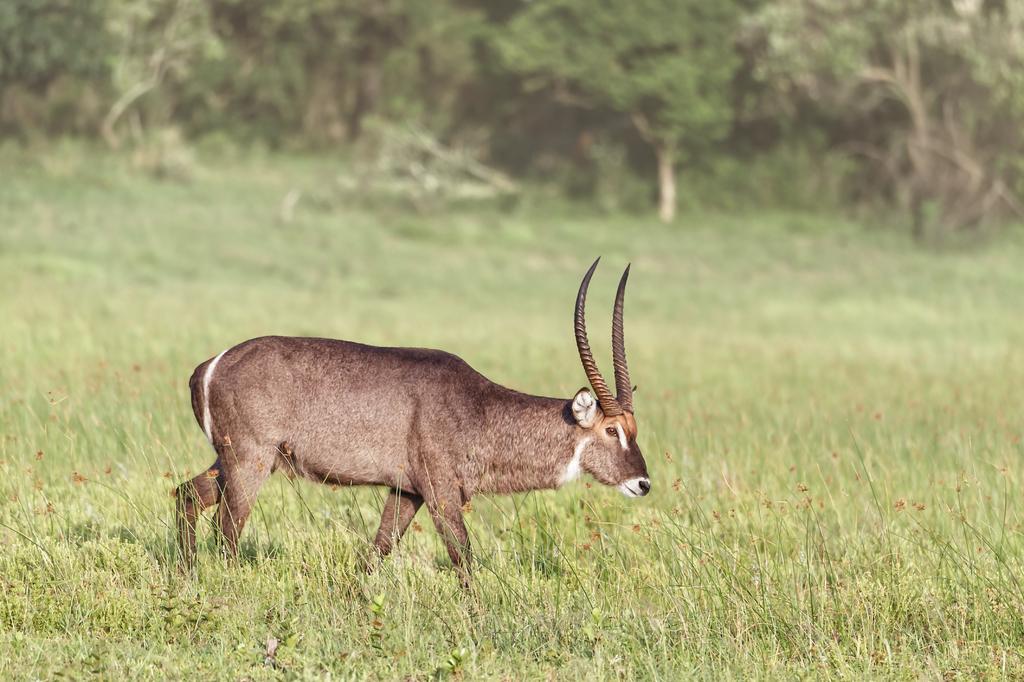Describe this image in one or two sentences. In this image I can see an animal which is in brown color and I can see grass and trees in green color. 